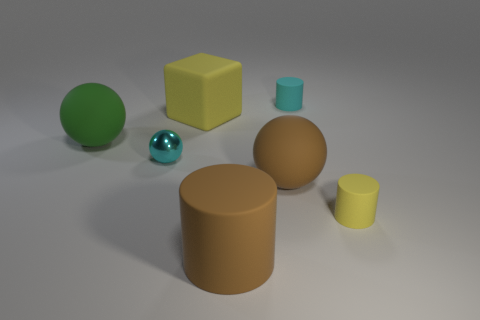What is the color of the large matte object that is the same shape as the tiny yellow rubber object? brown 